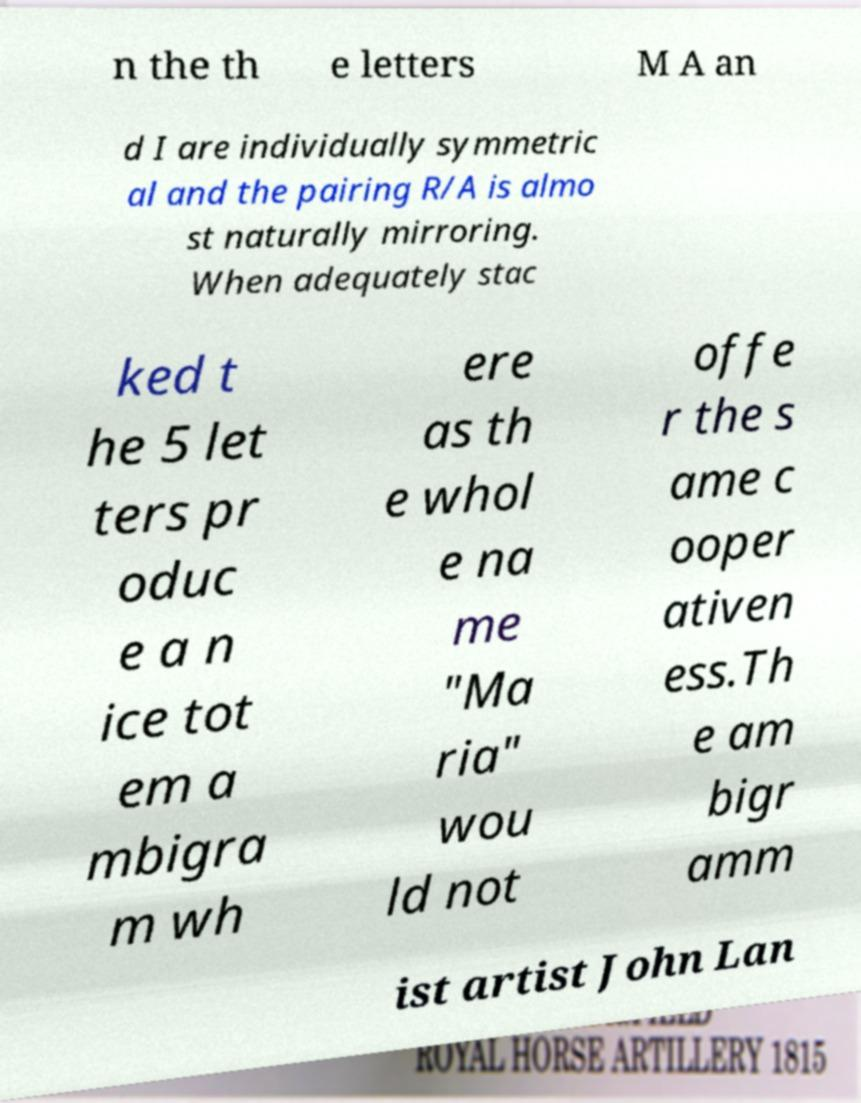Could you assist in decoding the text presented in this image and type it out clearly? n the th e letters M A an d I are individually symmetric al and the pairing R/A is almo st naturally mirroring. When adequately stac ked t he 5 let ters pr oduc e a n ice tot em a mbigra m wh ere as th e whol e na me "Ma ria" wou ld not offe r the s ame c ooper ativen ess.Th e am bigr amm ist artist John Lan 